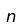Convert formula to latex. <formula><loc_0><loc_0><loc_500><loc_500>n</formula> 